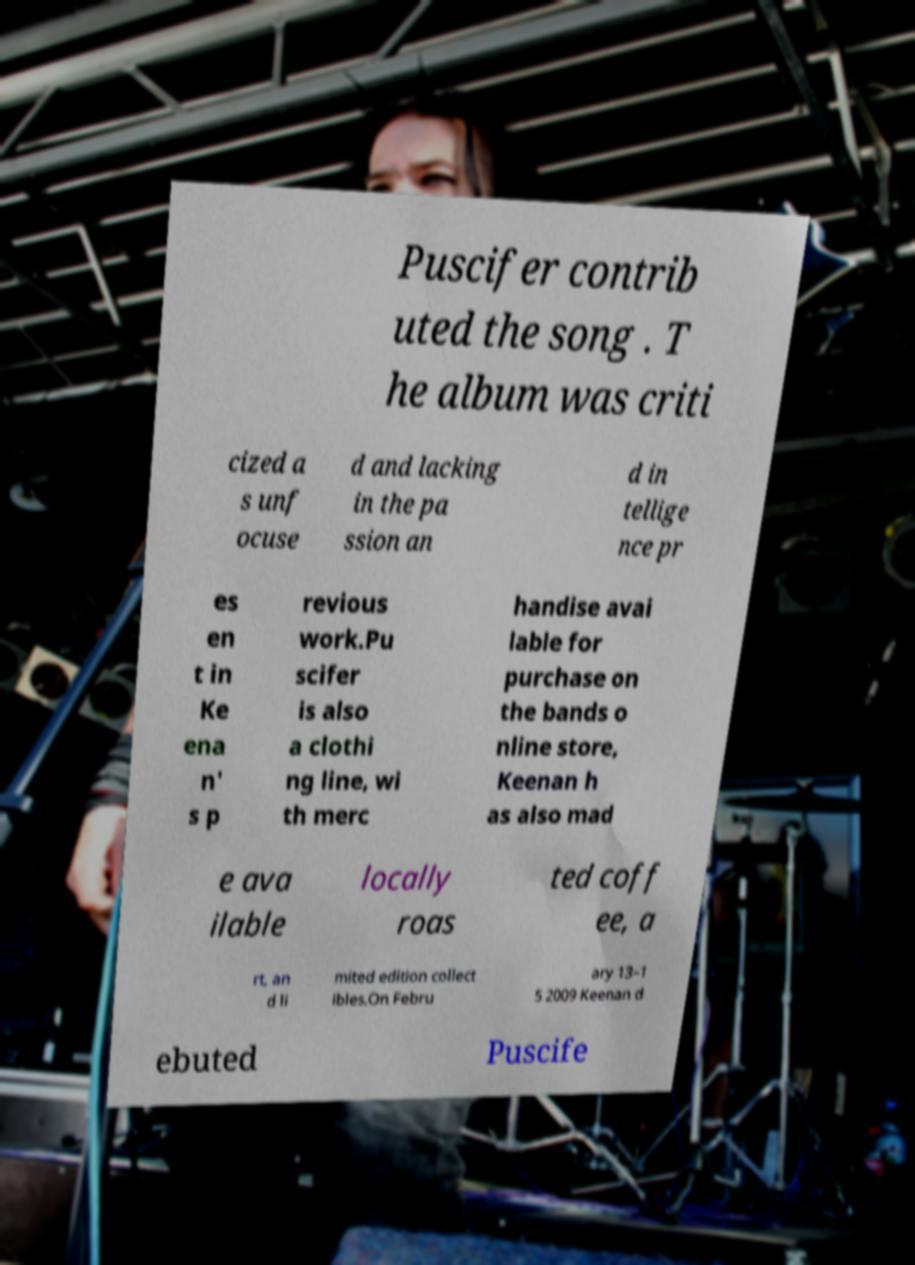There's text embedded in this image that I need extracted. Can you transcribe it verbatim? Puscifer contrib uted the song . T he album was criti cized a s unf ocuse d and lacking in the pa ssion an d in tellige nce pr es en t in Ke ena n' s p revious work.Pu scifer is also a clothi ng line, wi th merc handise avai lable for purchase on the bands o nline store, Keenan h as also mad e ava ilable locally roas ted coff ee, a rt, an d li mited edition collect ibles.On Febru ary 13–1 5 2009 Keenan d ebuted Puscife 